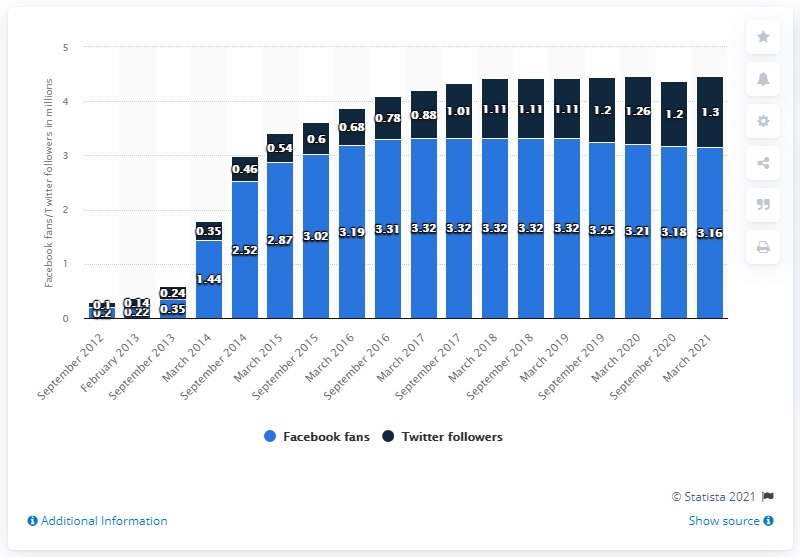Outline some significant characteristics in this image. As of March 2021, the Indiana Pacers basketball team had 3.16 million Facebook followers. 